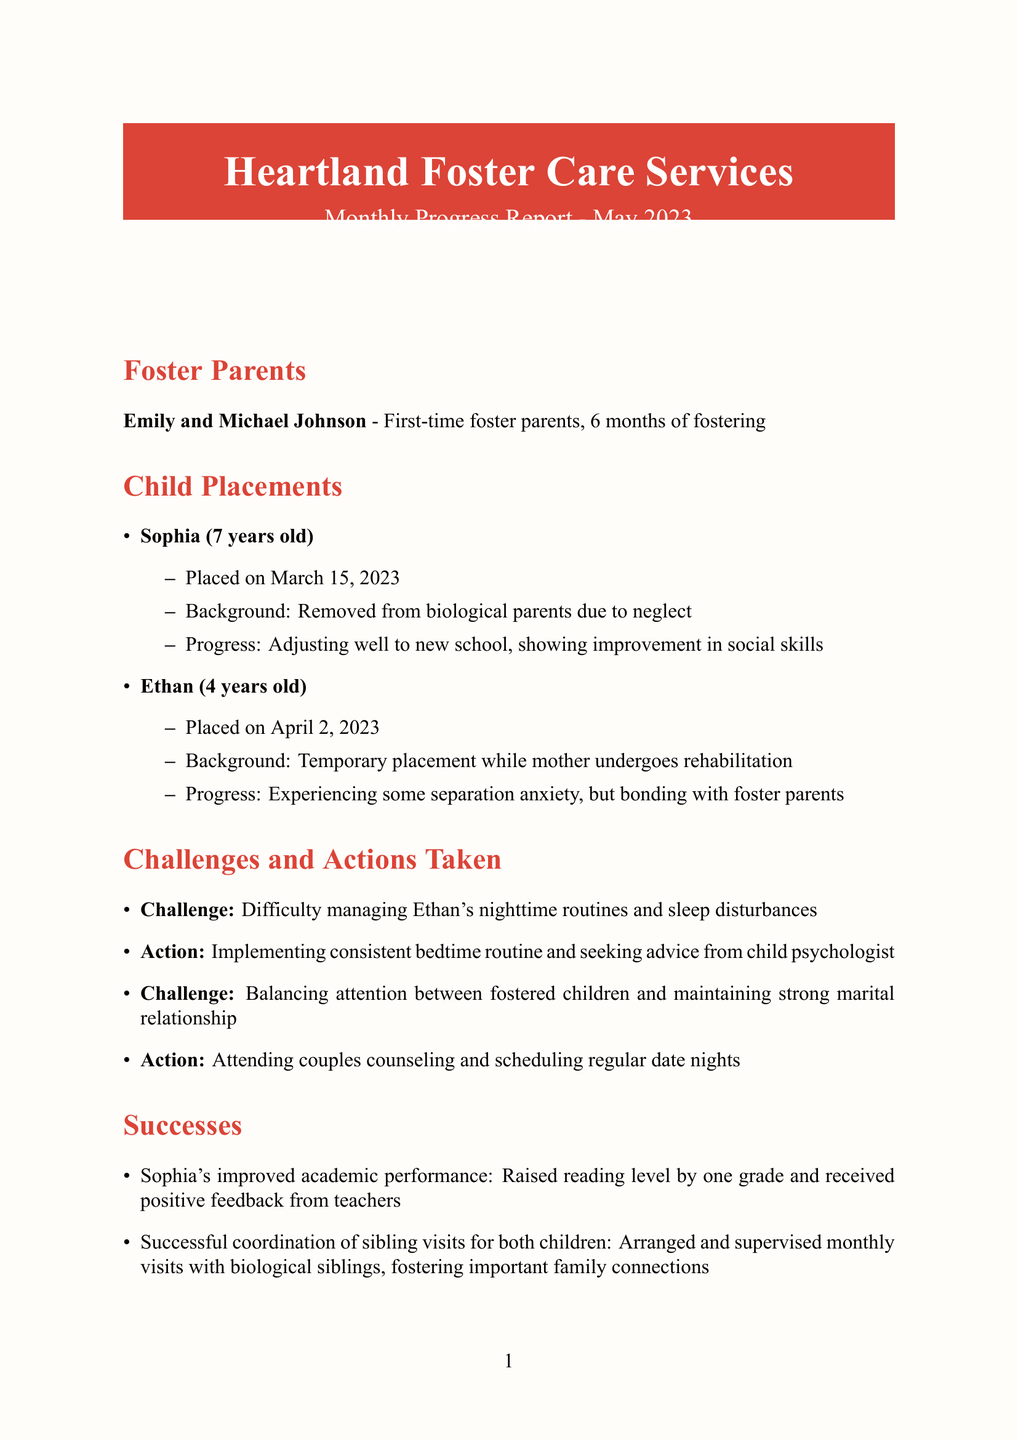What is the name of the agency? The document specifies the name of the agency as "Heartland Foster Care Services."
Answer: Heartland Foster Care Services How many months have Emily and Michael been fostering? The report states that they have six months of fostering experience.
Answer: 6 months What is Sophia's age? The document mentions that Sophia is 7 years old.
Answer: 7 What challenge is mentioned regarding Ethan? The report highlights difficulty managing Ethan's nighttime routines and sleep disturbances as a challenge.
Answer: Difficulty managing Ethan's nighttime routines and sleep disturbances What service is utilized once per month? Respite care is noted as a service utilized once per month in the report.
Answer: Respite care How has Sophia's academic performance improved? The document states that Sophia raised her reading level by one grade and received positive feedback from teachers.
Answer: Raised reading level by one grade What training course was completed on May 10, 2023? The report mentions that Emily and Michael completed "Trauma-Informed Care for Foster Children" on that date.
Answer: Trauma-Informed Care for Foster Children What is one of the goals for next month? The report lists several goals, including working with a speech therapist to address Ethan's language delay.
Answer: Work with speech therapist to address Ethan's language delay How often do they attend the foster parent support group? The document states that they attend the support group bi-weekly.
Answer: Bi-weekly What is the caseworker's overall comment about the couple? The caseworker comments on Emily and Michael's remarkable dedication and resilience.
Answer: Remarkable dedication and resilience 